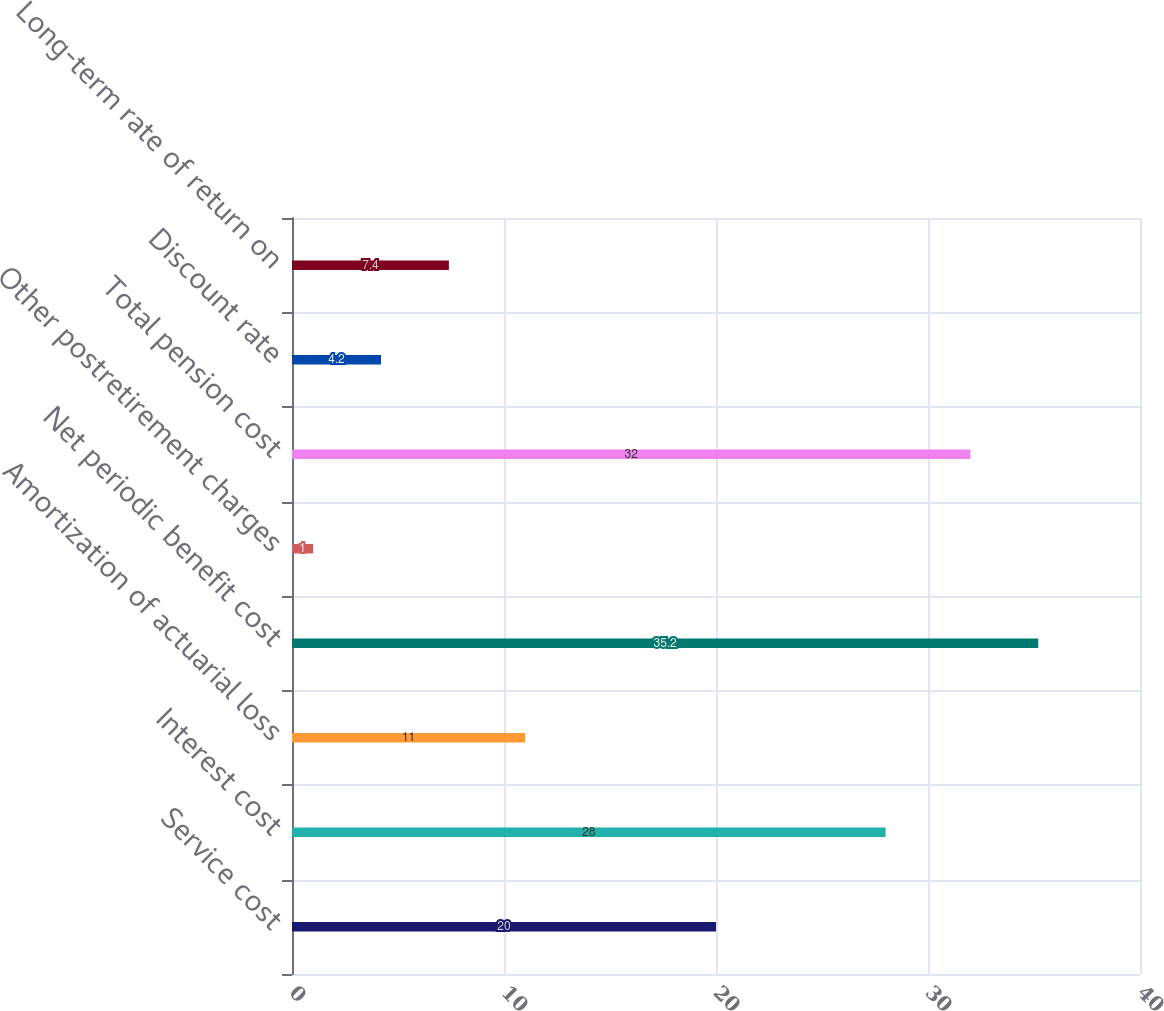Convert chart to OTSL. <chart><loc_0><loc_0><loc_500><loc_500><bar_chart><fcel>Service cost<fcel>Interest cost<fcel>Amortization of actuarial loss<fcel>Net periodic benefit cost<fcel>Other postretirement charges<fcel>Total pension cost<fcel>Discount rate<fcel>Long-term rate of return on<nl><fcel>20<fcel>28<fcel>11<fcel>35.2<fcel>1<fcel>32<fcel>4.2<fcel>7.4<nl></chart> 